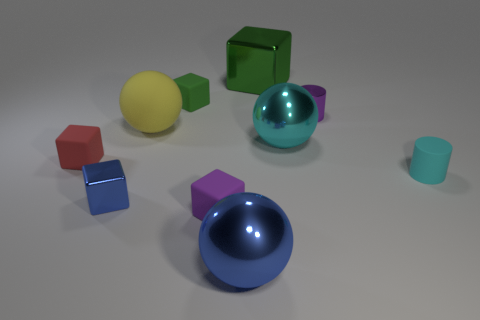Subtract all green matte blocks. How many blocks are left? 4 Subtract all cyan cylinders. How many cylinders are left? 1 Subtract all balls. How many objects are left? 7 Subtract 1 purple cylinders. How many objects are left? 9 Subtract 3 cubes. How many cubes are left? 2 Subtract all red cylinders. Subtract all cyan blocks. How many cylinders are left? 2 Subtract all brown spheres. How many cyan cubes are left? 0 Subtract all large brown shiny things. Subtract all small blue shiny blocks. How many objects are left? 9 Add 4 large metal blocks. How many large metal blocks are left? 5 Add 5 small blue blocks. How many small blue blocks exist? 6 